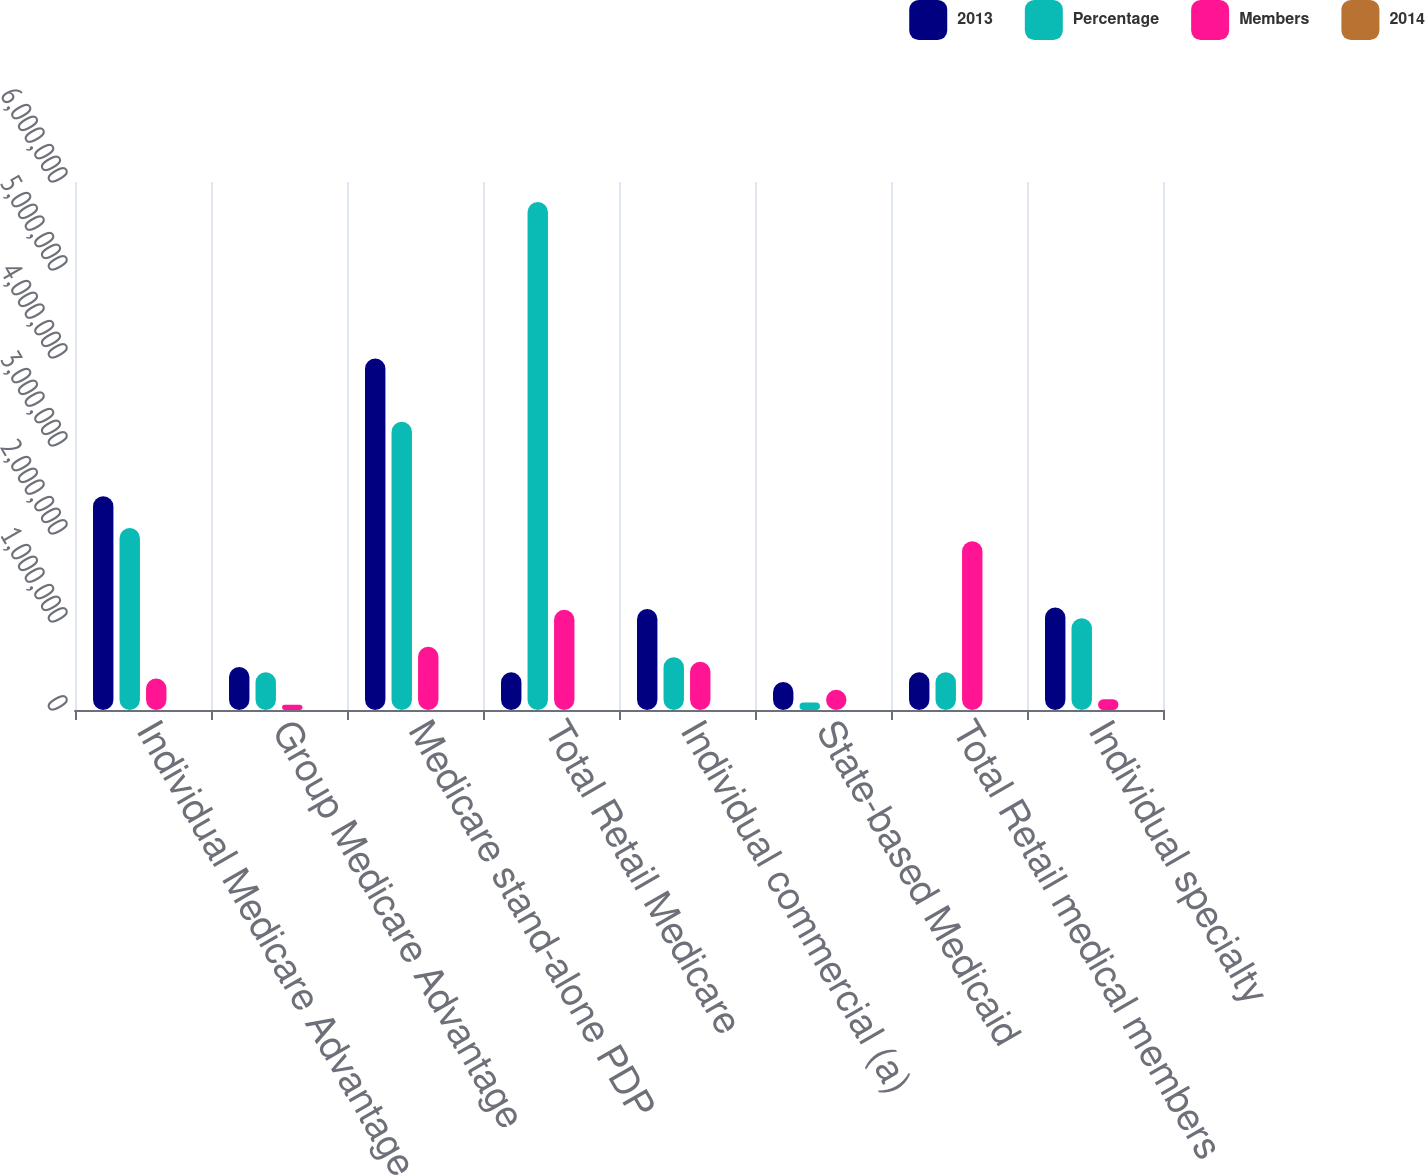<chart> <loc_0><loc_0><loc_500><loc_500><stacked_bar_chart><ecel><fcel>Individual Medicare Advantage<fcel>Group Medicare Advantage<fcel>Medicare stand-alone PDP<fcel>Total Retail Medicare<fcel>Individual commercial (a)<fcel>State-based Medicaid<fcel>Total Retail medical members<fcel>Individual specialty<nl><fcel>2013<fcel>2.4279e+06<fcel>489700<fcel>3.994e+06<fcel>429100<fcel>1.1481e+06<fcel>316800<fcel>429100<fcel>1.1658e+06<nl><fcel>Percentage<fcel>2.0687e+06<fcel>429100<fcel>3.2759e+06<fcel>5.7737e+06<fcel>600100<fcel>85500<fcel>429100<fcel>1.0425e+06<nl><fcel>Members<fcel>359200<fcel>60600<fcel>718100<fcel>1.1379e+06<fcel>548000<fcel>231300<fcel>1.9172e+06<fcel>123300<nl><fcel>2014<fcel>17.4<fcel>14.1<fcel>21.9<fcel>19.7<fcel>91.3<fcel>270.5<fcel>29.7<fcel>11.8<nl></chart> 